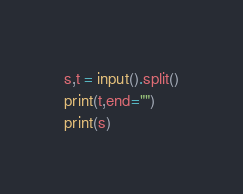Convert code to text. <code><loc_0><loc_0><loc_500><loc_500><_Python_>s,t = input().split()
print(t,end="")
print(s)</code> 